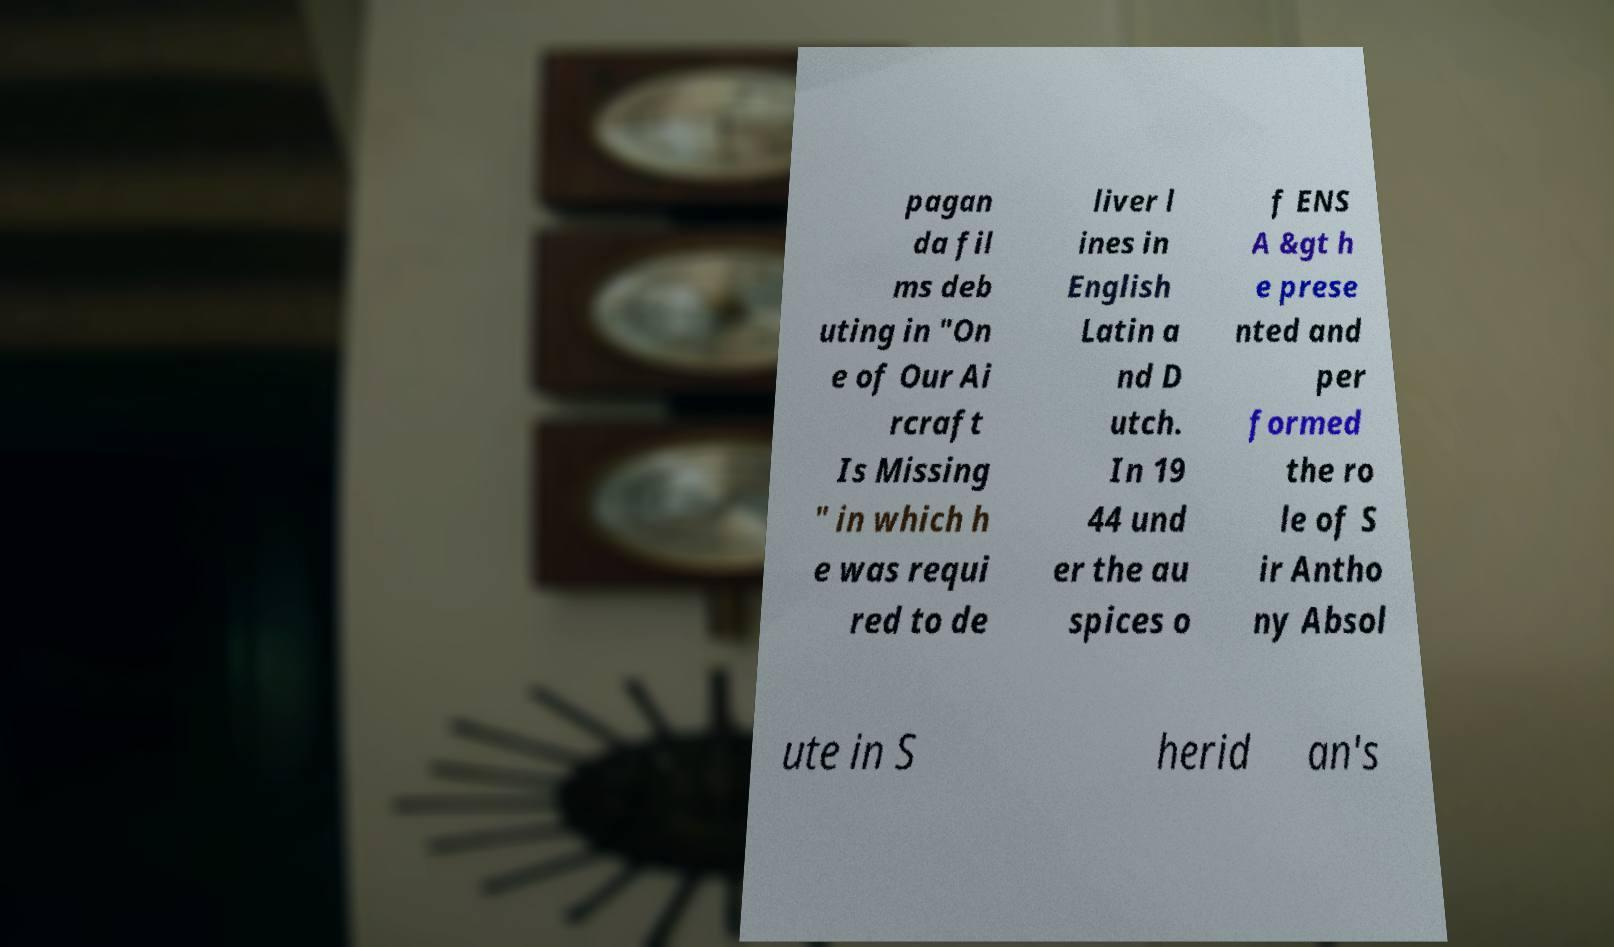Can you accurately transcribe the text from the provided image for me? pagan da fil ms deb uting in "On e of Our Ai rcraft Is Missing " in which h e was requi red to de liver l ines in English Latin a nd D utch. In 19 44 und er the au spices o f ENS A &gt h e prese nted and per formed the ro le of S ir Antho ny Absol ute in S herid an's 